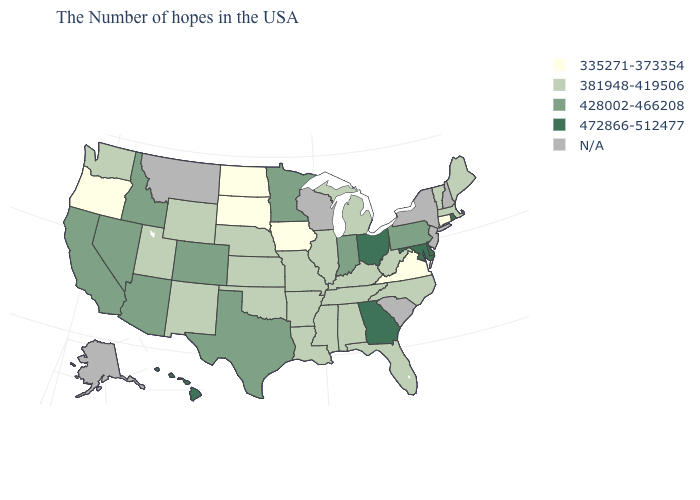What is the lowest value in the USA?
Keep it brief. 335271-373354. What is the value of West Virginia?
Give a very brief answer. 381948-419506. Which states hav the highest value in the West?
Short answer required. Hawaii. What is the lowest value in the MidWest?
Short answer required. 335271-373354. What is the value of Pennsylvania?
Give a very brief answer. 428002-466208. Name the states that have a value in the range 335271-373354?
Answer briefly. Connecticut, Virginia, Iowa, South Dakota, North Dakota, Oregon. What is the value of West Virginia?
Write a very short answer. 381948-419506. What is the lowest value in states that border South Dakota?
Concise answer only. 335271-373354. Which states hav the highest value in the South?
Short answer required. Delaware, Maryland, Georgia. What is the lowest value in states that border Maryland?
Give a very brief answer. 335271-373354. What is the value of Arkansas?
Concise answer only. 381948-419506. What is the highest value in states that border Nevada?
Answer briefly. 428002-466208. What is the highest value in the MidWest ?
Keep it brief. 472866-512477. Among the states that border Kentucky , does Ohio have the highest value?
Short answer required. Yes. Name the states that have a value in the range 335271-373354?
Give a very brief answer. Connecticut, Virginia, Iowa, South Dakota, North Dakota, Oregon. 